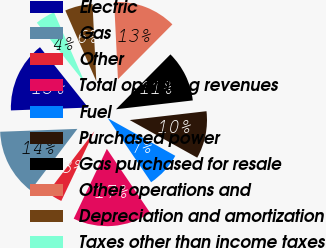Convert chart to OTSL. <chart><loc_0><loc_0><loc_500><loc_500><pie_chart><fcel>Electric<fcel>Gas<fcel>Other<fcel>Total operating revenues<fcel>Fuel<fcel>Purchased power<fcel>Gas purchased for resale<fcel>Other operations and<fcel>Depreciation and amortization<fcel>Taxes other than income taxes<nl><fcel>14.87%<fcel>14.05%<fcel>3.31%<fcel>16.52%<fcel>7.44%<fcel>9.92%<fcel>10.74%<fcel>13.22%<fcel>5.79%<fcel>4.14%<nl></chart> 